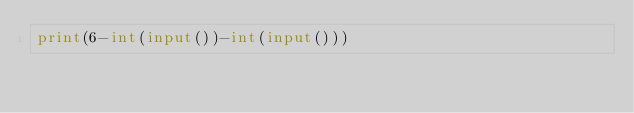Convert code to text. <code><loc_0><loc_0><loc_500><loc_500><_Python_>print(6-int(input())-int(input()))</code> 